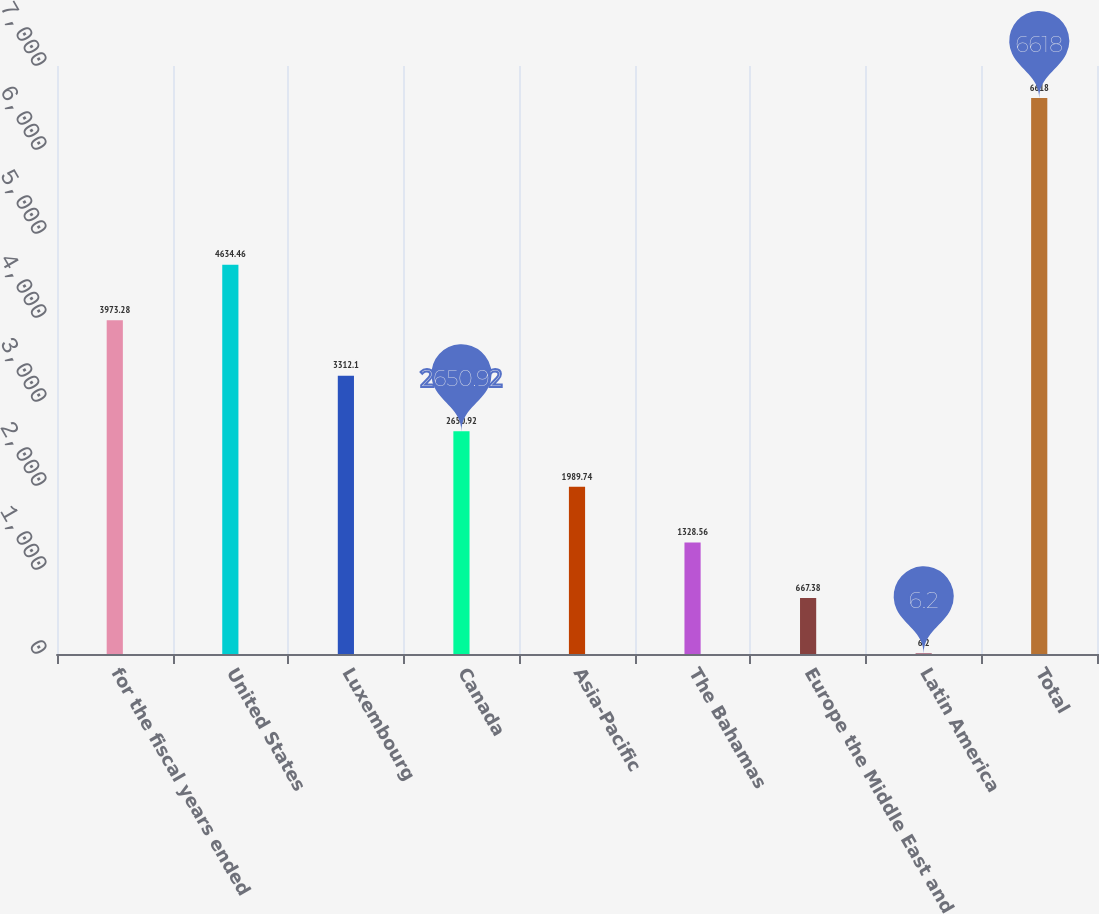Convert chart. <chart><loc_0><loc_0><loc_500><loc_500><bar_chart><fcel>for the fiscal years ended<fcel>United States<fcel>Luxembourg<fcel>Canada<fcel>Asia-Pacific<fcel>The Bahamas<fcel>Europe the Middle East and<fcel>Latin America<fcel>Total<nl><fcel>3973.28<fcel>4634.46<fcel>3312.1<fcel>2650.92<fcel>1989.74<fcel>1328.56<fcel>667.38<fcel>6.2<fcel>6618<nl></chart> 